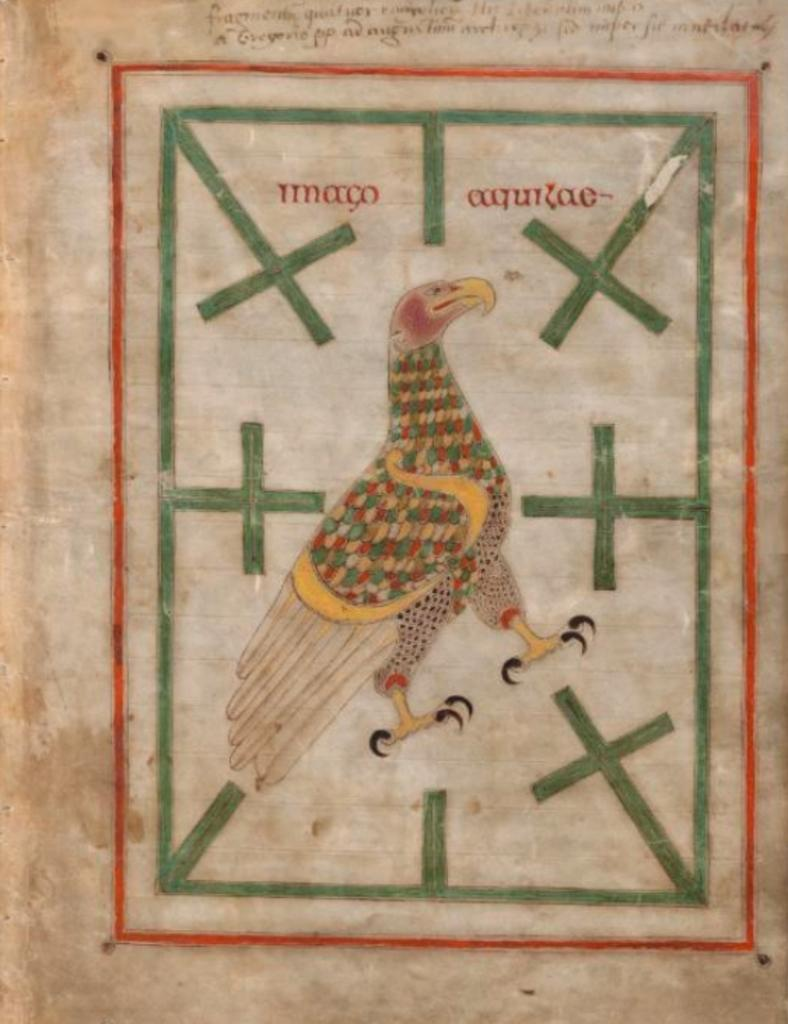What is the main object in the image? There is a paper in the image. What is depicted on the paper? The paper has a picture of an eagle. What else can be seen on the paper besides the picture? There are symbols and letters on the paper. What type of pipe is being used to write the prose on the paper? There is no pipe or prose present in the image; it only features a paper with a picture of an eagle, symbols, and letters. 